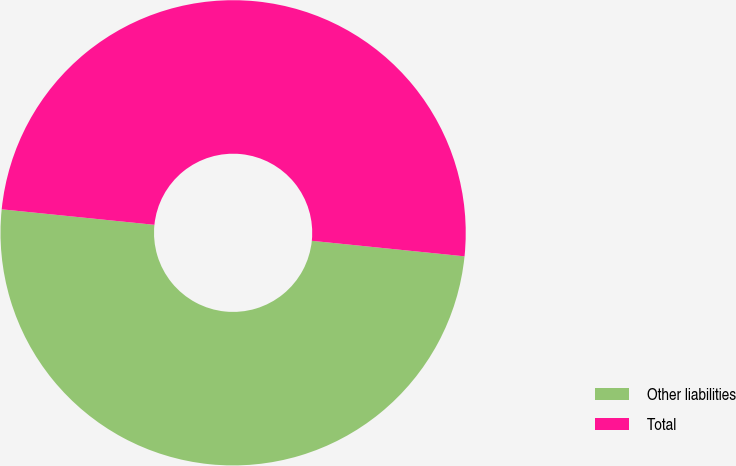<chart> <loc_0><loc_0><loc_500><loc_500><pie_chart><fcel>Other liabilities<fcel>Total<nl><fcel>50.0%<fcel>50.0%<nl></chart> 